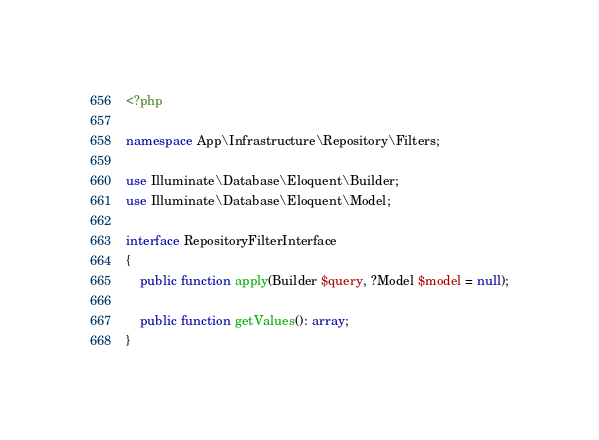<code> <loc_0><loc_0><loc_500><loc_500><_PHP_><?php

namespace App\Infrastructure\Repository\Filters;

use Illuminate\Database\Eloquent\Builder;
use Illuminate\Database\Eloquent\Model;

interface RepositoryFilterInterface
{
    public function apply(Builder $query, ?Model $model = null);

    public function getValues(): array;
}
</code> 